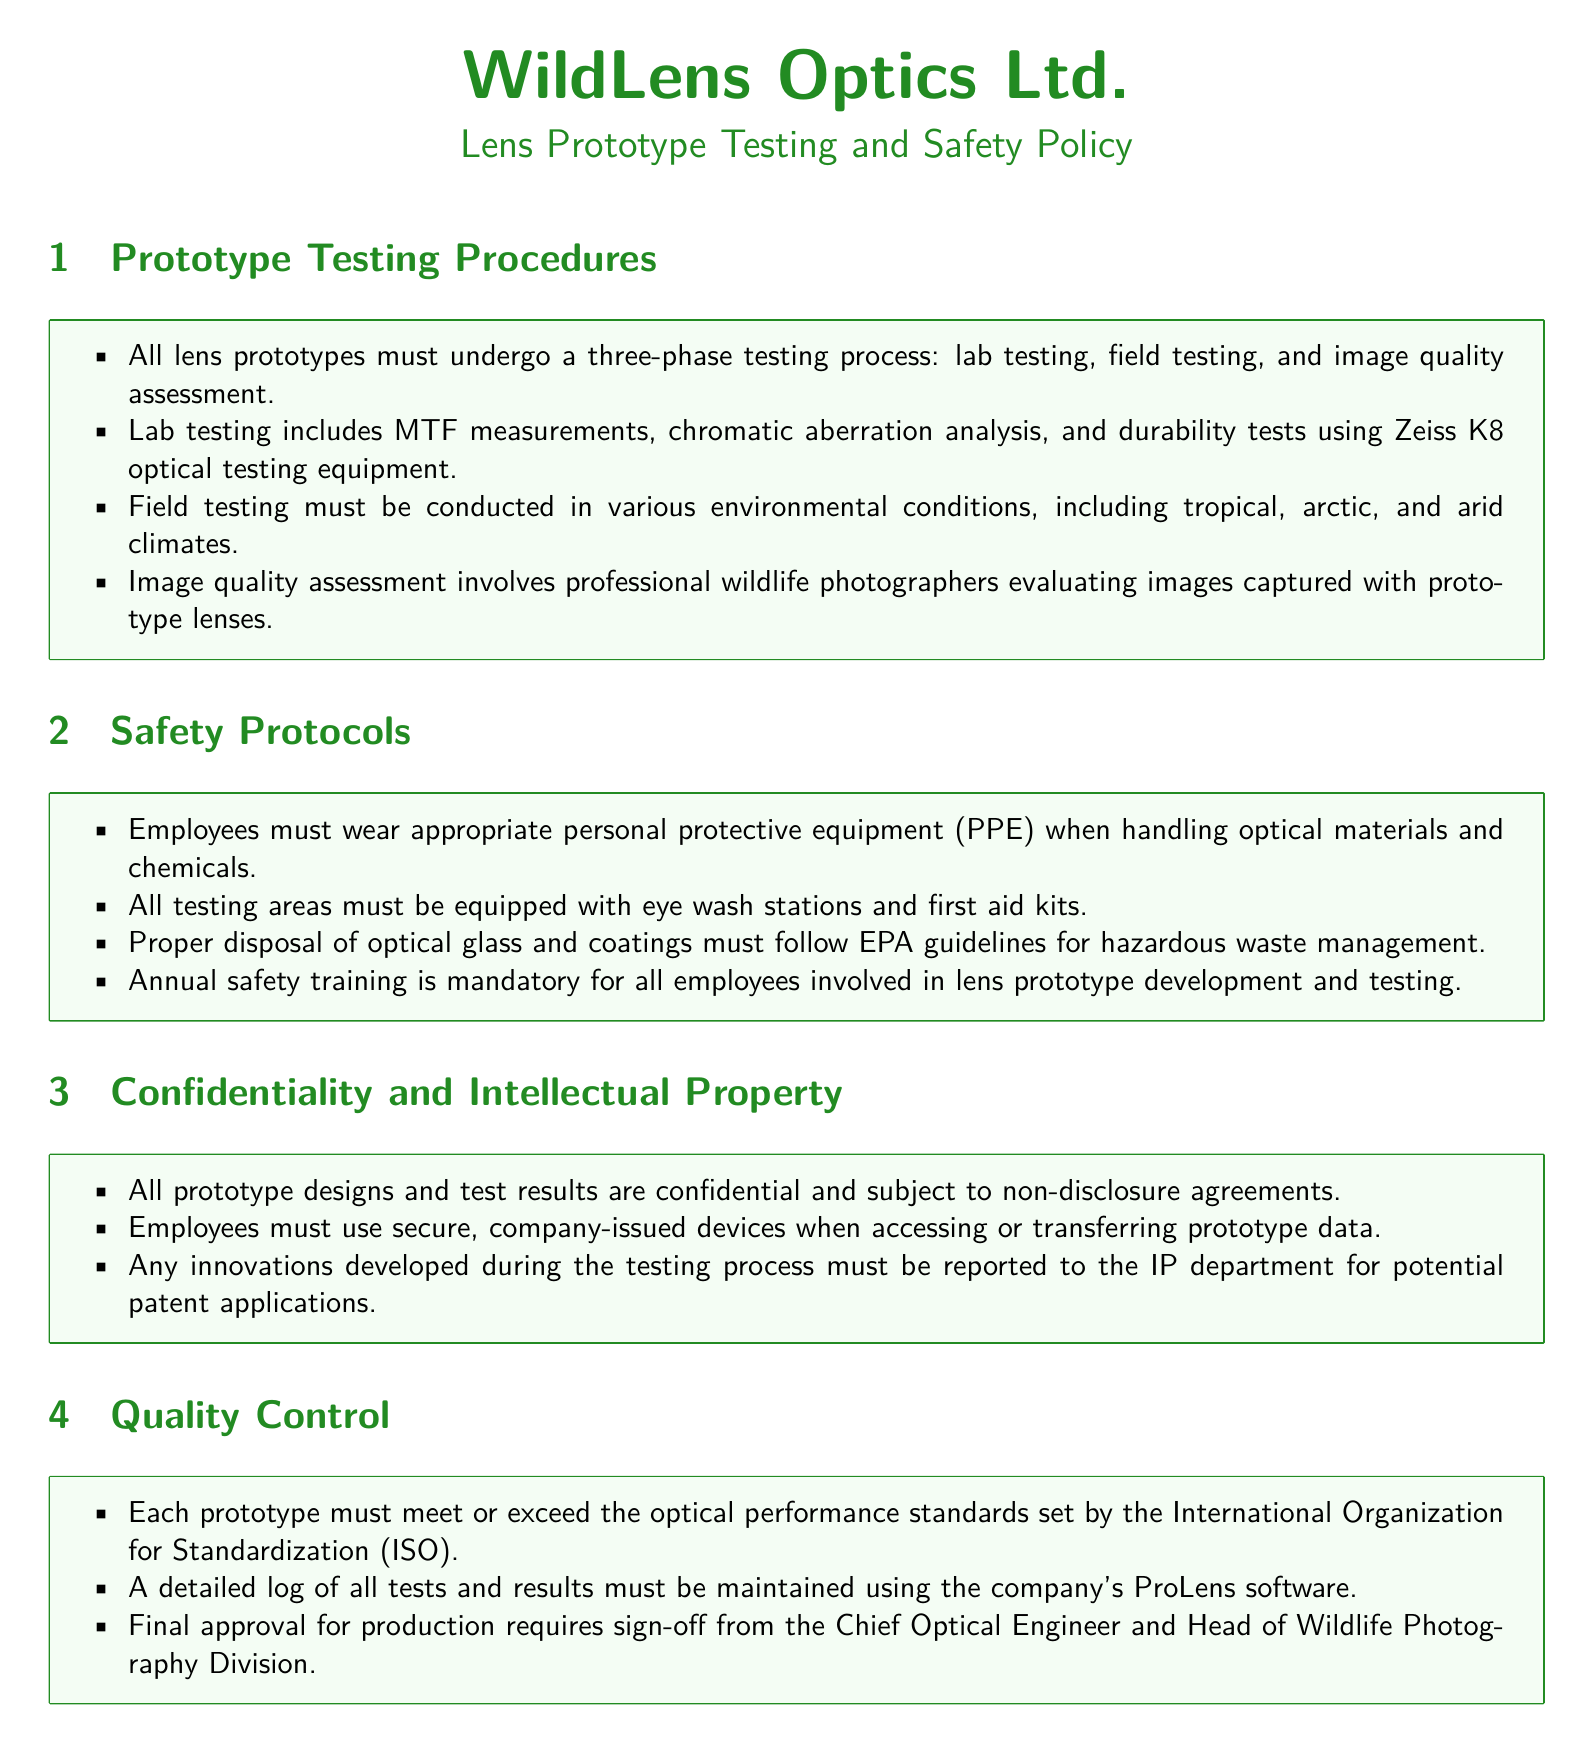What are the three phases of lens prototype testing? The phases include lab testing, field testing, and image quality assessment.
Answer: lab testing, field testing, image quality assessment Which optical testing equipment is used during lab testing? The document mentions the Zeiss K8 optical testing equipment for lab tests.
Answer: Zeiss K8 What climates must field testing include? The required climates for field testing include tropical, arctic, and arid conditions.
Answer: tropical, arctic, arid What is mandatory for all employees involved in lens prototype development? The document states that annual safety training is mandatory for these employees.
Answer: annual safety training Who must sign off on final production approval? The Chief Optical Engineer and the Head of Wildlife Photography Division both must sign off for approval.
Answer: Chief Optical Engineer and Head of Wildlife Photography Division 